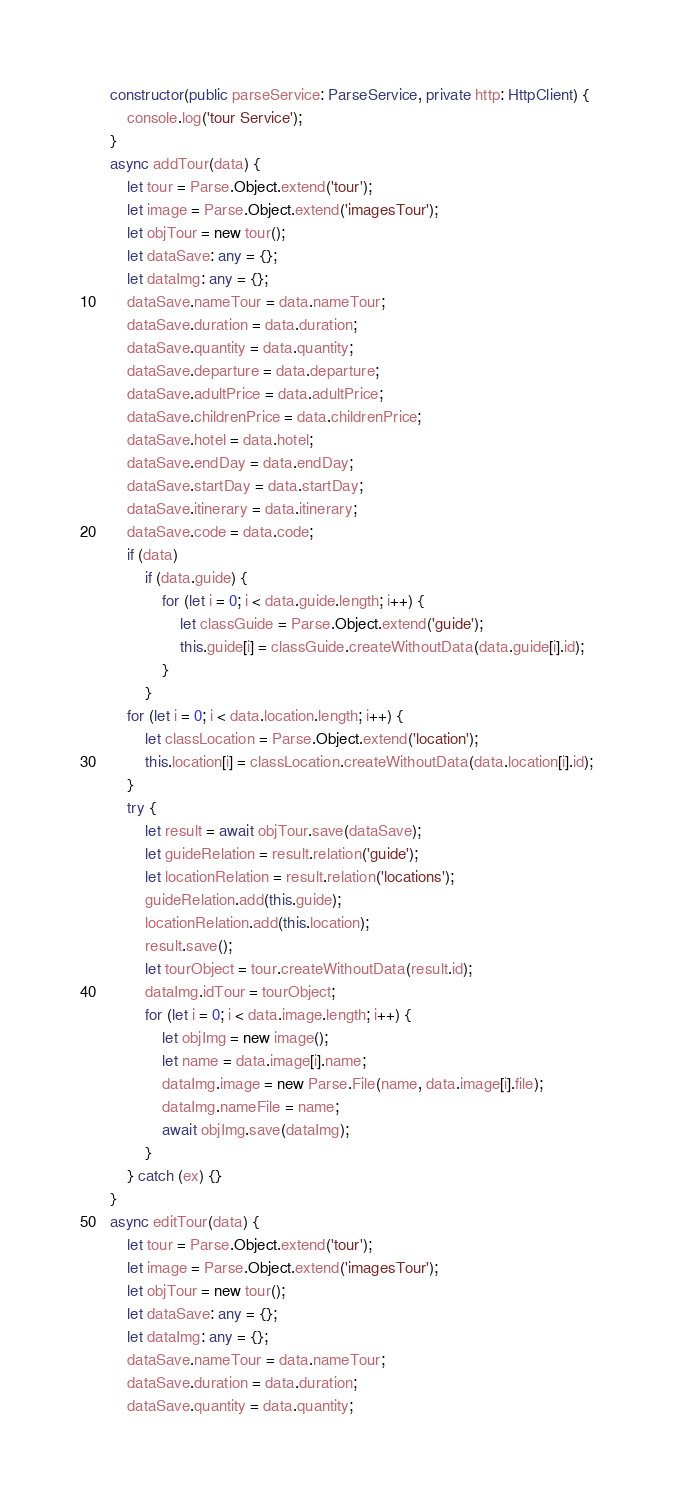Convert code to text. <code><loc_0><loc_0><loc_500><loc_500><_TypeScript_>
    constructor(public parseService: ParseService, private http: HttpClient) {
        console.log('tour Service');
    }
    async addTour(data) {
        let tour = Parse.Object.extend('tour');
        let image = Parse.Object.extend('imagesTour');
        let objTour = new tour();
        let dataSave: any = {};
        let dataImg: any = {};
        dataSave.nameTour = data.nameTour;
        dataSave.duration = data.duration;
        dataSave.quantity = data.quantity;
        dataSave.departure = data.departure;
        dataSave.adultPrice = data.adultPrice;
        dataSave.childrenPrice = data.childrenPrice;
        dataSave.hotel = data.hotel;
        dataSave.endDay = data.endDay;
        dataSave.startDay = data.startDay;
        dataSave.itinerary = data.itinerary;
        dataSave.code = data.code;
        if (data)
            if (data.guide) {
                for (let i = 0; i < data.guide.length; i++) {
                    let classGuide = Parse.Object.extend('guide');
                    this.guide[i] = classGuide.createWithoutData(data.guide[i].id);
                }
            }
        for (let i = 0; i < data.location.length; i++) {
            let classLocation = Parse.Object.extend('location');
            this.location[i] = classLocation.createWithoutData(data.location[i].id);
        }
        try {
            let result = await objTour.save(dataSave);
            let guideRelation = result.relation('guide');
            let locationRelation = result.relation('locations');
            guideRelation.add(this.guide);
            locationRelation.add(this.location);
            result.save();
            let tourObject = tour.createWithoutData(result.id);
            dataImg.idTour = tourObject;
            for (let i = 0; i < data.image.length; i++) {
                let objImg = new image();
                let name = data.image[i].name;
                dataImg.image = new Parse.File(name, data.image[i].file);
                dataImg.nameFile = name;
                await objImg.save(dataImg);
            }
        } catch (ex) {}
    }
    async editTour(data) {
        let tour = Parse.Object.extend('tour');
        let image = Parse.Object.extend('imagesTour');
        let objTour = new tour();
        let dataSave: any = {};
        let dataImg: any = {};
        dataSave.nameTour = data.nameTour;
        dataSave.duration = data.duration;
        dataSave.quantity = data.quantity;</code> 